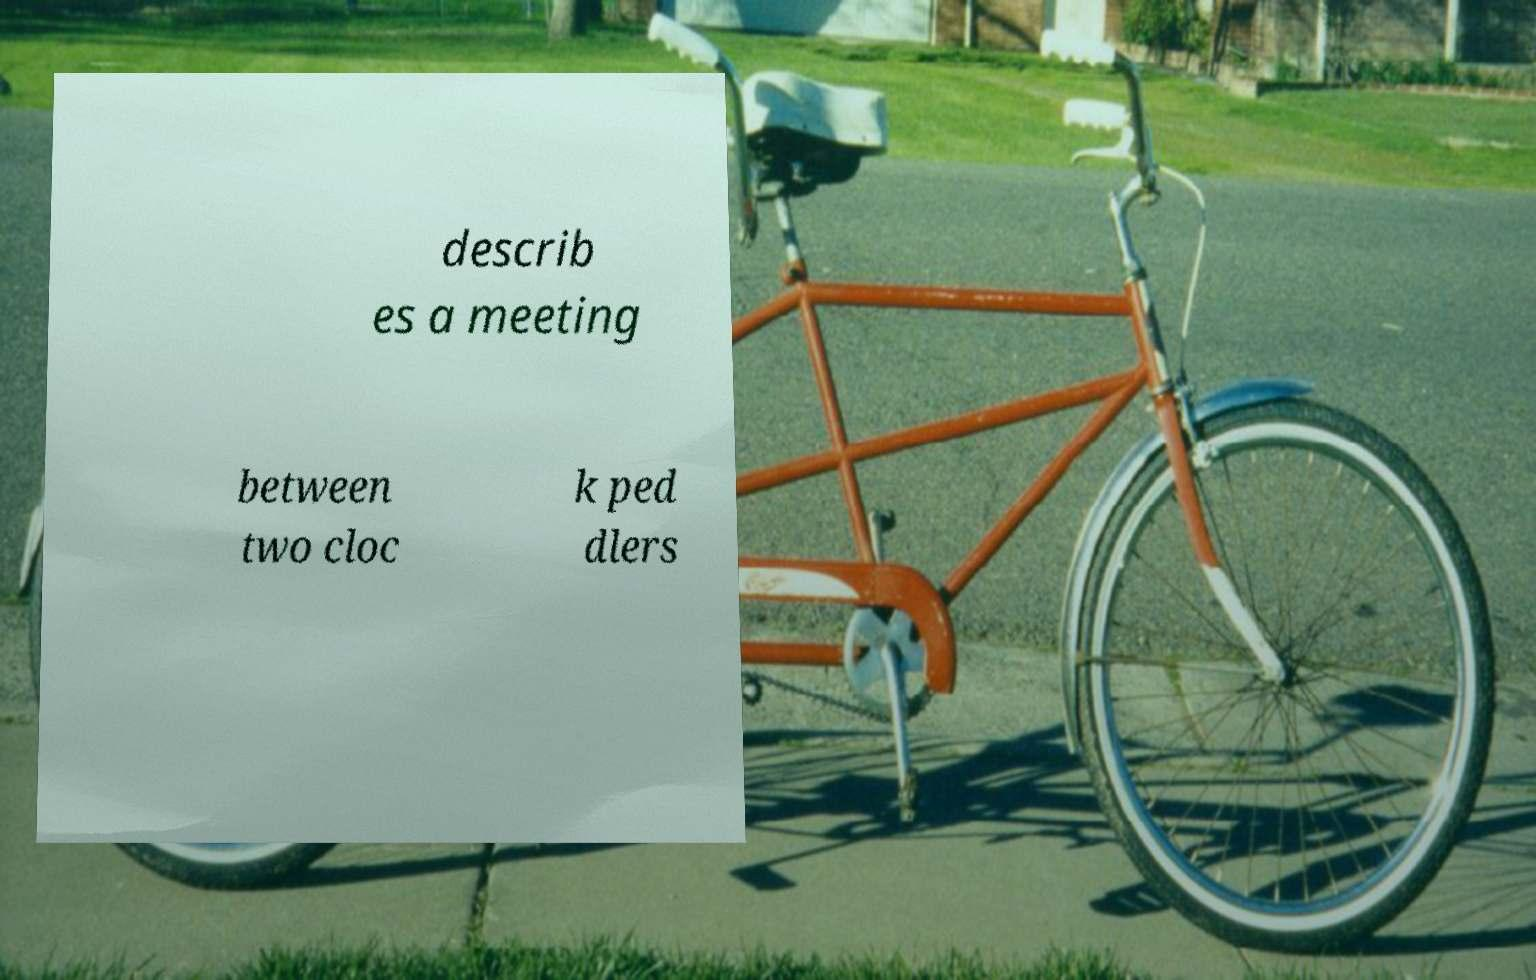For documentation purposes, I need the text within this image transcribed. Could you provide that? describ es a meeting between two cloc k ped dlers 